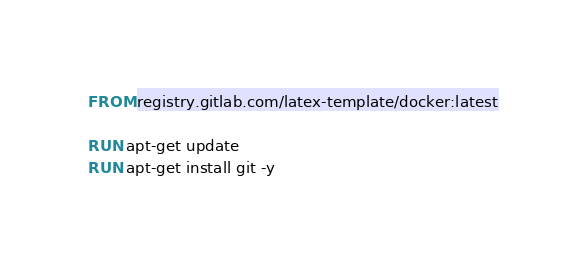Convert code to text. <code><loc_0><loc_0><loc_500><loc_500><_Dockerfile_>FROM registry.gitlab.com/latex-template/docker:latest

RUN apt-get update
RUN apt-get install git -y</code> 